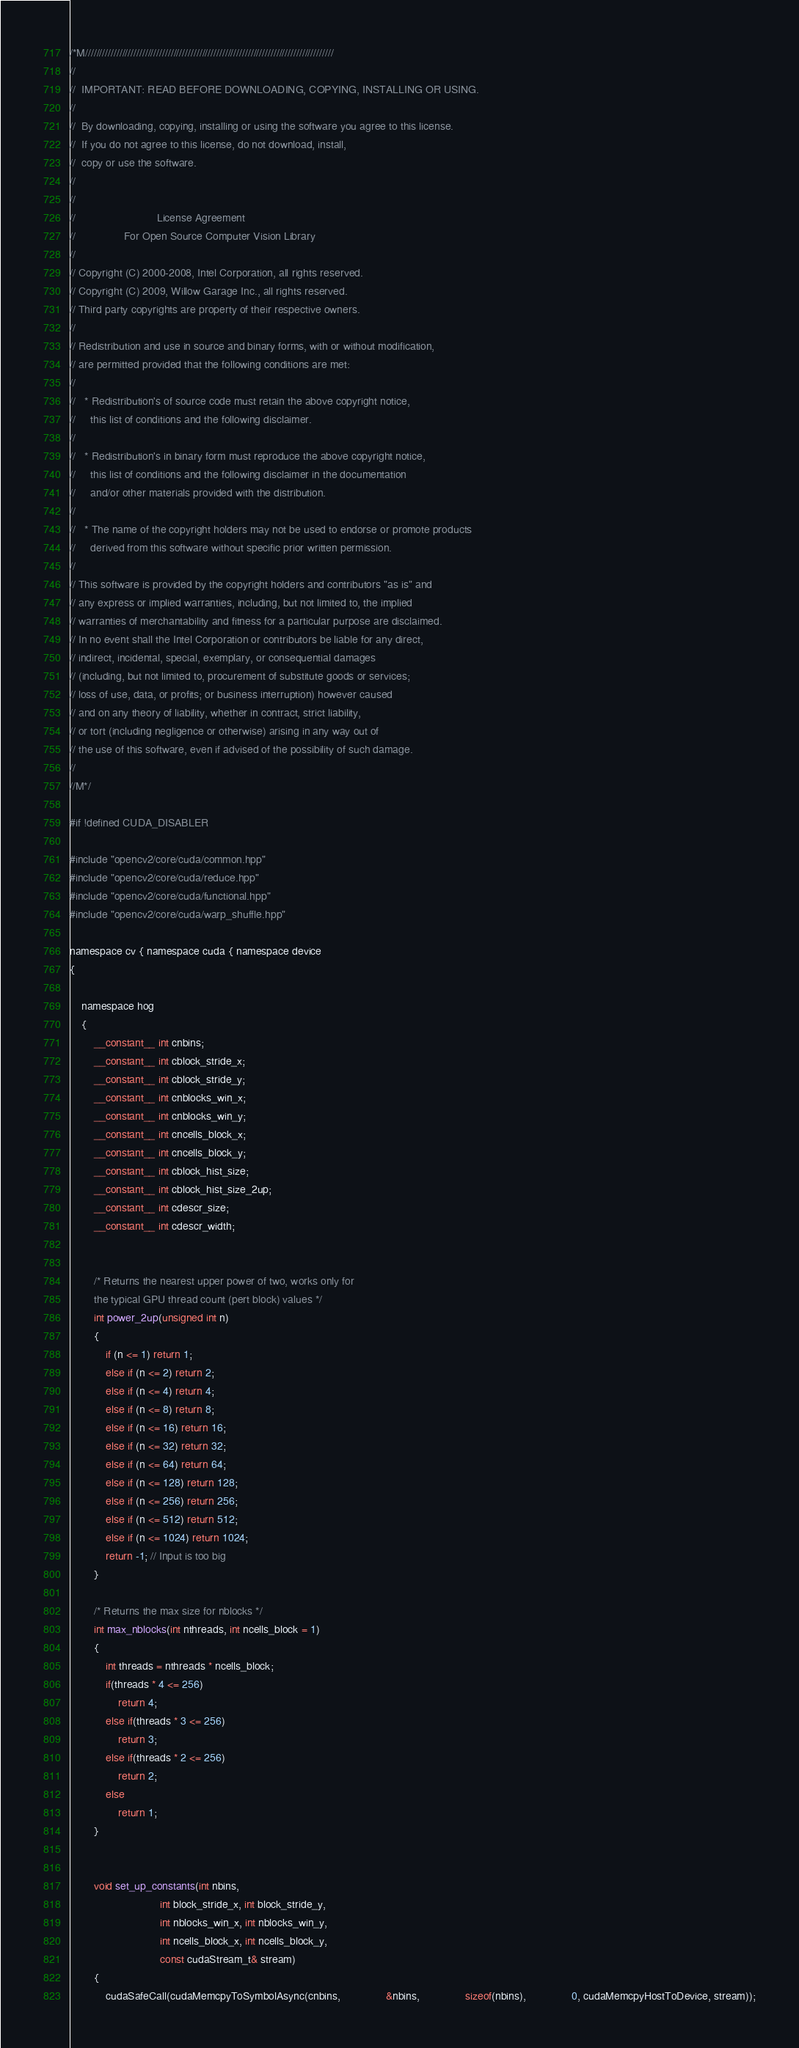<code> <loc_0><loc_0><loc_500><loc_500><_Cuda_>/*M///////////////////////////////////////////////////////////////////////////////////////
//
//  IMPORTANT: READ BEFORE DOWNLOADING, COPYING, INSTALLING OR USING.
//
//  By downloading, copying, installing or using the software you agree to this license.
//  If you do not agree to this license, do not download, install,
//  copy or use the software.
//
//
//                           License Agreement
//                For Open Source Computer Vision Library
//
// Copyright (C) 2000-2008, Intel Corporation, all rights reserved.
// Copyright (C) 2009, Willow Garage Inc., all rights reserved.
// Third party copyrights are property of their respective owners.
//
// Redistribution and use in source and binary forms, with or without modification,
// are permitted provided that the following conditions are met:
//
//   * Redistribution's of source code must retain the above copyright notice,
//     this list of conditions and the following disclaimer.
//
//   * Redistribution's in binary form must reproduce the above copyright notice,
//     this list of conditions and the following disclaimer in the documentation
//     and/or other materials provided with the distribution.
//
//   * The name of the copyright holders may not be used to endorse or promote products
//     derived from this software without specific prior written permission.
//
// This software is provided by the copyright holders and contributors "as is" and
// any express or implied warranties, including, but not limited to, the implied
// warranties of merchantability and fitness for a particular purpose are disclaimed.
// In no event shall the Intel Corporation or contributors be liable for any direct,
// indirect, incidental, special, exemplary, or consequential damages
// (including, but not limited to, procurement of substitute goods or services;
// loss of use, data, or profits; or business interruption) however caused
// and on any theory of liability, whether in contract, strict liability,
// or tort (including negligence or otherwise) arising in any way out of
// the use of this software, even if advised of the possibility of such damage.
//
//M*/

#if !defined CUDA_DISABLER

#include "opencv2/core/cuda/common.hpp"
#include "opencv2/core/cuda/reduce.hpp"
#include "opencv2/core/cuda/functional.hpp"
#include "opencv2/core/cuda/warp_shuffle.hpp"

namespace cv { namespace cuda { namespace device
{

    namespace hog
    {
        __constant__ int cnbins;
        __constant__ int cblock_stride_x;
        __constant__ int cblock_stride_y;
        __constant__ int cnblocks_win_x;
        __constant__ int cnblocks_win_y;
        __constant__ int cncells_block_x;
        __constant__ int cncells_block_y;
        __constant__ int cblock_hist_size;
        __constant__ int cblock_hist_size_2up;
        __constant__ int cdescr_size;
        __constant__ int cdescr_width;


        /* Returns the nearest upper power of two, works only for
        the typical GPU thread count (pert block) values */
        int power_2up(unsigned int n)
        {
            if (n <= 1) return 1;
            else if (n <= 2) return 2;
            else if (n <= 4) return 4;
            else if (n <= 8) return 8;
            else if (n <= 16) return 16;
            else if (n <= 32) return 32;
            else if (n <= 64) return 64;
            else if (n <= 128) return 128;
            else if (n <= 256) return 256;
            else if (n <= 512) return 512;
            else if (n <= 1024) return 1024;
            return -1; // Input is too big
        }

        /* Returns the max size for nblocks */
        int max_nblocks(int nthreads, int ncells_block = 1)
        {
            int threads = nthreads * ncells_block;
            if(threads * 4 <= 256)
                return 4;
            else if(threads * 3 <= 256)
                return 3;
            else if(threads * 2 <= 256)
                return 2;
            else
                return 1;
        }


        void set_up_constants(int nbins,
                              int block_stride_x, int block_stride_y,
                              int nblocks_win_x, int nblocks_win_y,
                              int ncells_block_x, int ncells_block_y,
                              const cudaStream_t& stream)
        {
            cudaSafeCall(cudaMemcpyToSymbolAsync(cnbins,               &nbins,               sizeof(nbins),               0, cudaMemcpyHostToDevice, stream));</code> 